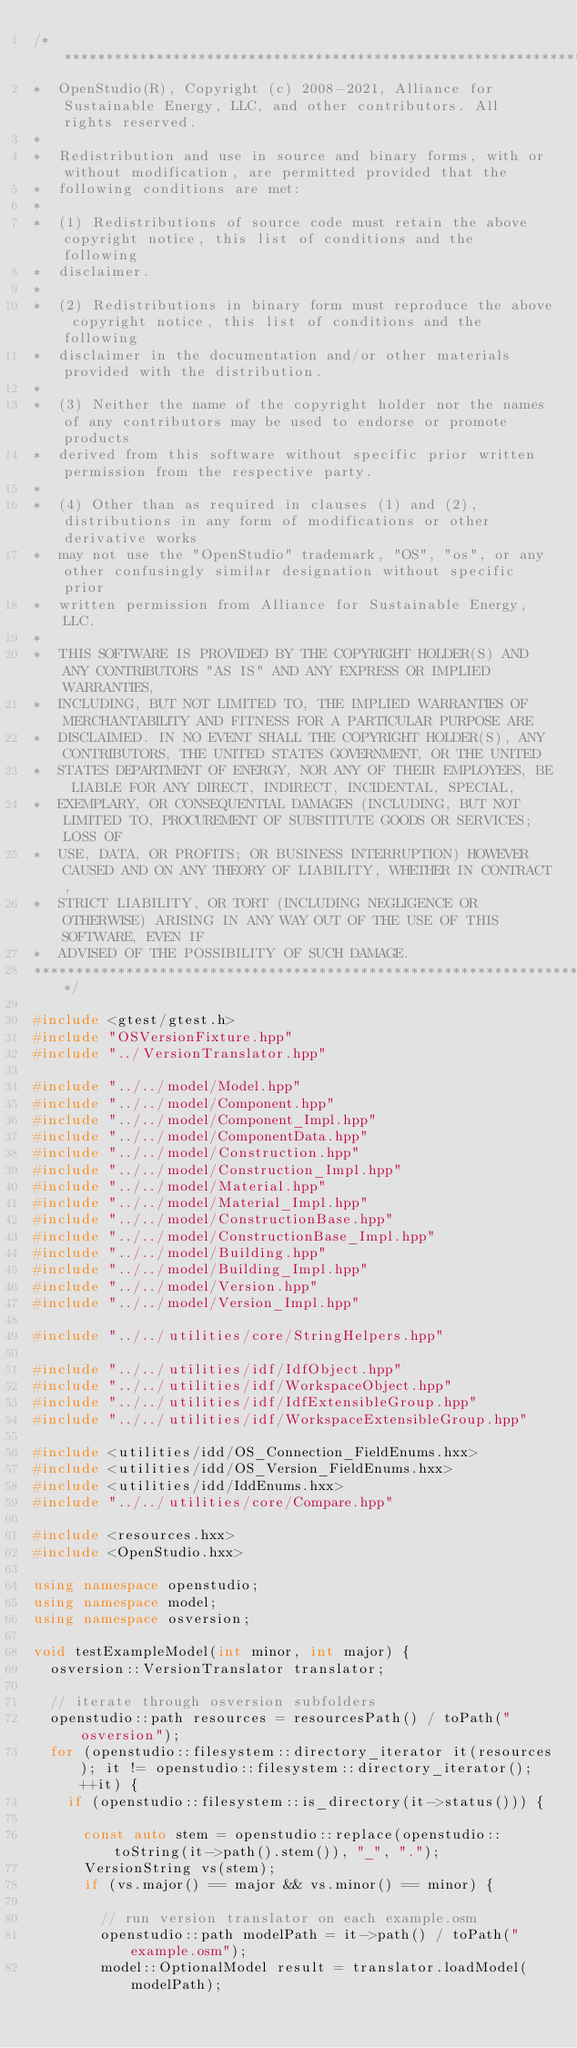<code> <loc_0><loc_0><loc_500><loc_500><_C++_>/***********************************************************************************************************************
*  OpenStudio(R), Copyright (c) 2008-2021, Alliance for Sustainable Energy, LLC, and other contributors. All rights reserved.
*
*  Redistribution and use in source and binary forms, with or without modification, are permitted provided that the
*  following conditions are met:
*
*  (1) Redistributions of source code must retain the above copyright notice, this list of conditions and the following
*  disclaimer.
*
*  (2) Redistributions in binary form must reproduce the above copyright notice, this list of conditions and the following
*  disclaimer in the documentation and/or other materials provided with the distribution.
*
*  (3) Neither the name of the copyright holder nor the names of any contributors may be used to endorse or promote products
*  derived from this software without specific prior written permission from the respective party.
*
*  (4) Other than as required in clauses (1) and (2), distributions in any form of modifications or other derivative works
*  may not use the "OpenStudio" trademark, "OS", "os", or any other confusingly similar designation without specific prior
*  written permission from Alliance for Sustainable Energy, LLC.
*
*  THIS SOFTWARE IS PROVIDED BY THE COPYRIGHT HOLDER(S) AND ANY CONTRIBUTORS "AS IS" AND ANY EXPRESS OR IMPLIED WARRANTIES,
*  INCLUDING, BUT NOT LIMITED TO, THE IMPLIED WARRANTIES OF MERCHANTABILITY AND FITNESS FOR A PARTICULAR PURPOSE ARE
*  DISCLAIMED. IN NO EVENT SHALL THE COPYRIGHT HOLDER(S), ANY CONTRIBUTORS, THE UNITED STATES GOVERNMENT, OR THE UNITED
*  STATES DEPARTMENT OF ENERGY, NOR ANY OF THEIR EMPLOYEES, BE LIABLE FOR ANY DIRECT, INDIRECT, INCIDENTAL, SPECIAL,
*  EXEMPLARY, OR CONSEQUENTIAL DAMAGES (INCLUDING, BUT NOT LIMITED TO, PROCUREMENT OF SUBSTITUTE GOODS OR SERVICES; LOSS OF
*  USE, DATA, OR PROFITS; OR BUSINESS INTERRUPTION) HOWEVER CAUSED AND ON ANY THEORY OF LIABILITY, WHETHER IN CONTRACT,
*  STRICT LIABILITY, OR TORT (INCLUDING NEGLIGENCE OR OTHERWISE) ARISING IN ANY WAY OUT OF THE USE OF THIS SOFTWARE, EVEN IF
*  ADVISED OF THE POSSIBILITY OF SUCH DAMAGE.
***********************************************************************************************************************/

#include <gtest/gtest.h>
#include "OSVersionFixture.hpp"
#include "../VersionTranslator.hpp"

#include "../../model/Model.hpp"
#include "../../model/Component.hpp"
#include "../../model/Component_Impl.hpp"
#include "../../model/ComponentData.hpp"
#include "../../model/Construction.hpp"
#include "../../model/Construction_Impl.hpp"
#include "../../model/Material.hpp"
#include "../../model/Material_Impl.hpp"
#include "../../model/ConstructionBase.hpp"
#include "../../model/ConstructionBase_Impl.hpp"
#include "../../model/Building.hpp"
#include "../../model/Building_Impl.hpp"
#include "../../model/Version.hpp"
#include "../../model/Version_Impl.hpp"

#include "../../utilities/core/StringHelpers.hpp"

#include "../../utilities/idf/IdfObject.hpp"
#include "../../utilities/idf/WorkspaceObject.hpp"
#include "../../utilities/idf/IdfExtensibleGroup.hpp"
#include "../../utilities/idf/WorkspaceExtensibleGroup.hpp"

#include <utilities/idd/OS_Connection_FieldEnums.hxx>
#include <utilities/idd/OS_Version_FieldEnums.hxx>
#include <utilities/idd/IddEnums.hxx>
#include "../../utilities/core/Compare.hpp"

#include <resources.hxx>
#include <OpenStudio.hxx>

using namespace openstudio;
using namespace model;
using namespace osversion;

void testExampleModel(int minor, int major) {
  osversion::VersionTranslator translator;

  // iterate through osversion subfolders
  openstudio::path resources = resourcesPath() / toPath("osversion");
  for (openstudio::filesystem::directory_iterator it(resources); it != openstudio::filesystem::directory_iterator(); ++it) {
    if (openstudio::filesystem::is_directory(it->status())) {

      const auto stem = openstudio::replace(openstudio::toString(it->path().stem()), "_", ".");
      VersionString vs(stem);
      if (vs.major() == major && vs.minor() == minor) {

        // run version translator on each example.osm
        openstudio::path modelPath = it->path() / toPath("example.osm");
        model::OptionalModel result = translator.loadModel(modelPath);</code> 